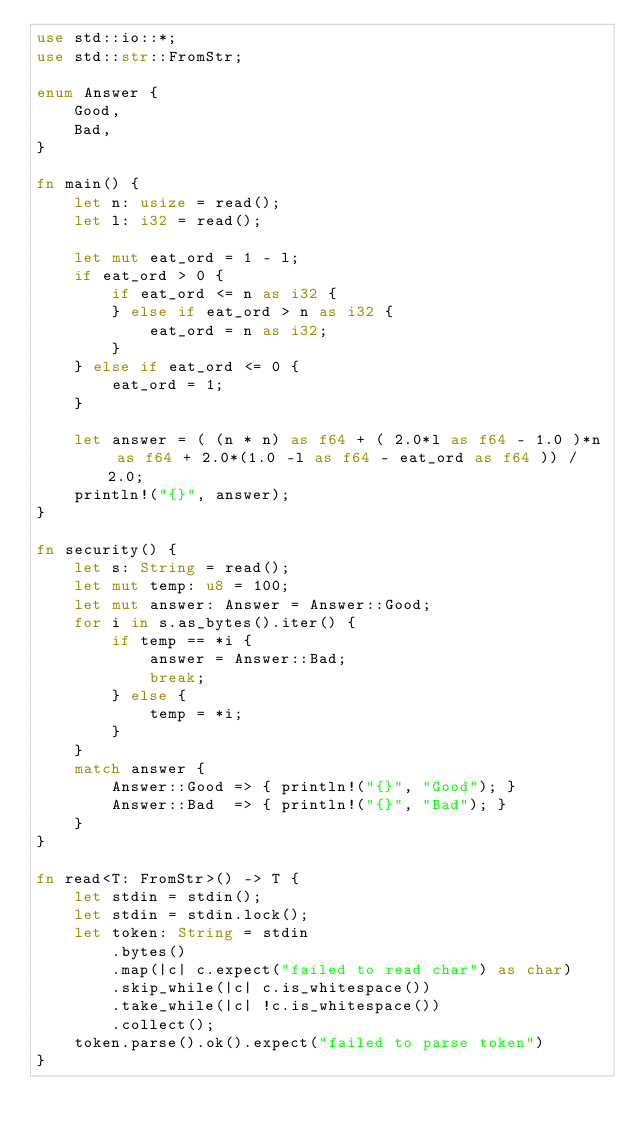Convert code to text. <code><loc_0><loc_0><loc_500><loc_500><_Rust_>use std::io::*;
use std::str::FromStr;

enum Answer {
    Good,
    Bad,
}

fn main() {
    let n: usize = read();
    let l: i32 = read();

    let mut eat_ord = 1 - l;
    if eat_ord > 0 {
        if eat_ord <= n as i32 {
        } else if eat_ord > n as i32 {
            eat_ord = n as i32;
        }
    } else if eat_ord <= 0 {
        eat_ord = 1;
    }

    let answer = ( (n * n) as f64 + ( 2.0*l as f64 - 1.0 )*n as f64 + 2.0*(1.0 -l as f64 - eat_ord as f64 )) / 2.0;
    println!("{}", answer);
}

fn security() {
    let s: String = read();
    let mut temp: u8 = 100; 
    let mut answer: Answer = Answer::Good;
    for i in s.as_bytes().iter() {
        if temp == *i {
            answer = Answer::Bad;
            break;
        } else {
            temp = *i;
        }
    }
    match answer {
        Answer::Good => { println!("{}", "Good"); }
        Answer::Bad  => { println!("{}", "Bad"); }
    }
}

fn read<T: FromStr>() -> T {
    let stdin = stdin();
    let stdin = stdin.lock();
    let token: String = stdin
        .bytes()
        .map(|c| c.expect("failed to read char") as char)
        .skip_while(|c| c.is_whitespace())
        .take_while(|c| !c.is_whitespace())
        .collect();
    token.parse().ok().expect("failed to parse token")
}
</code> 